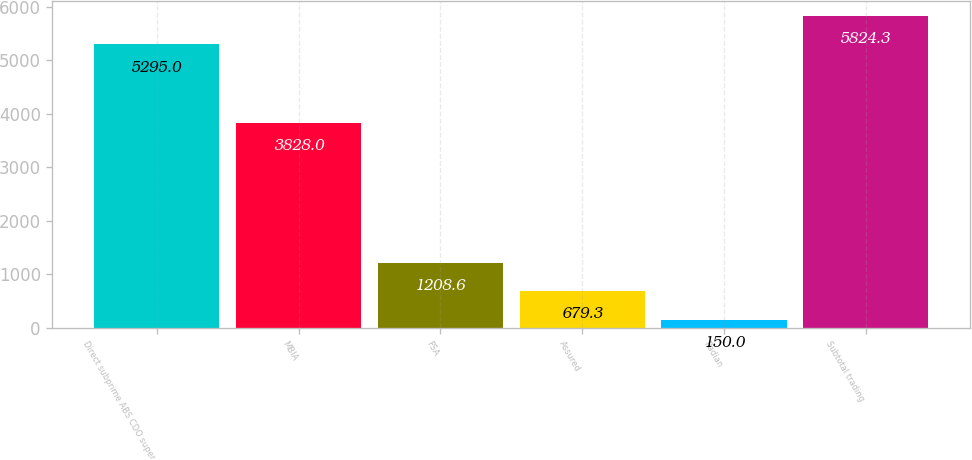Convert chart to OTSL. <chart><loc_0><loc_0><loc_500><loc_500><bar_chart><fcel>Direct subprime ABS CDO super<fcel>MBIA<fcel>FSA<fcel>Assured<fcel>Radian<fcel>Subtotal trading<nl><fcel>5295<fcel>3828<fcel>1208.6<fcel>679.3<fcel>150<fcel>5824.3<nl></chart> 